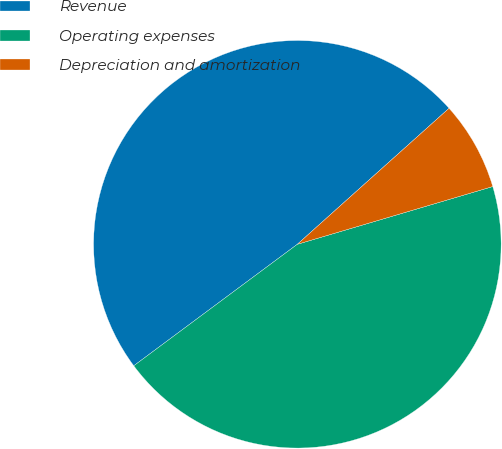Convert chart. <chart><loc_0><loc_0><loc_500><loc_500><pie_chart><fcel>Revenue<fcel>Operating expenses<fcel>Depreciation and amortization<nl><fcel>48.54%<fcel>44.41%<fcel>7.06%<nl></chart> 